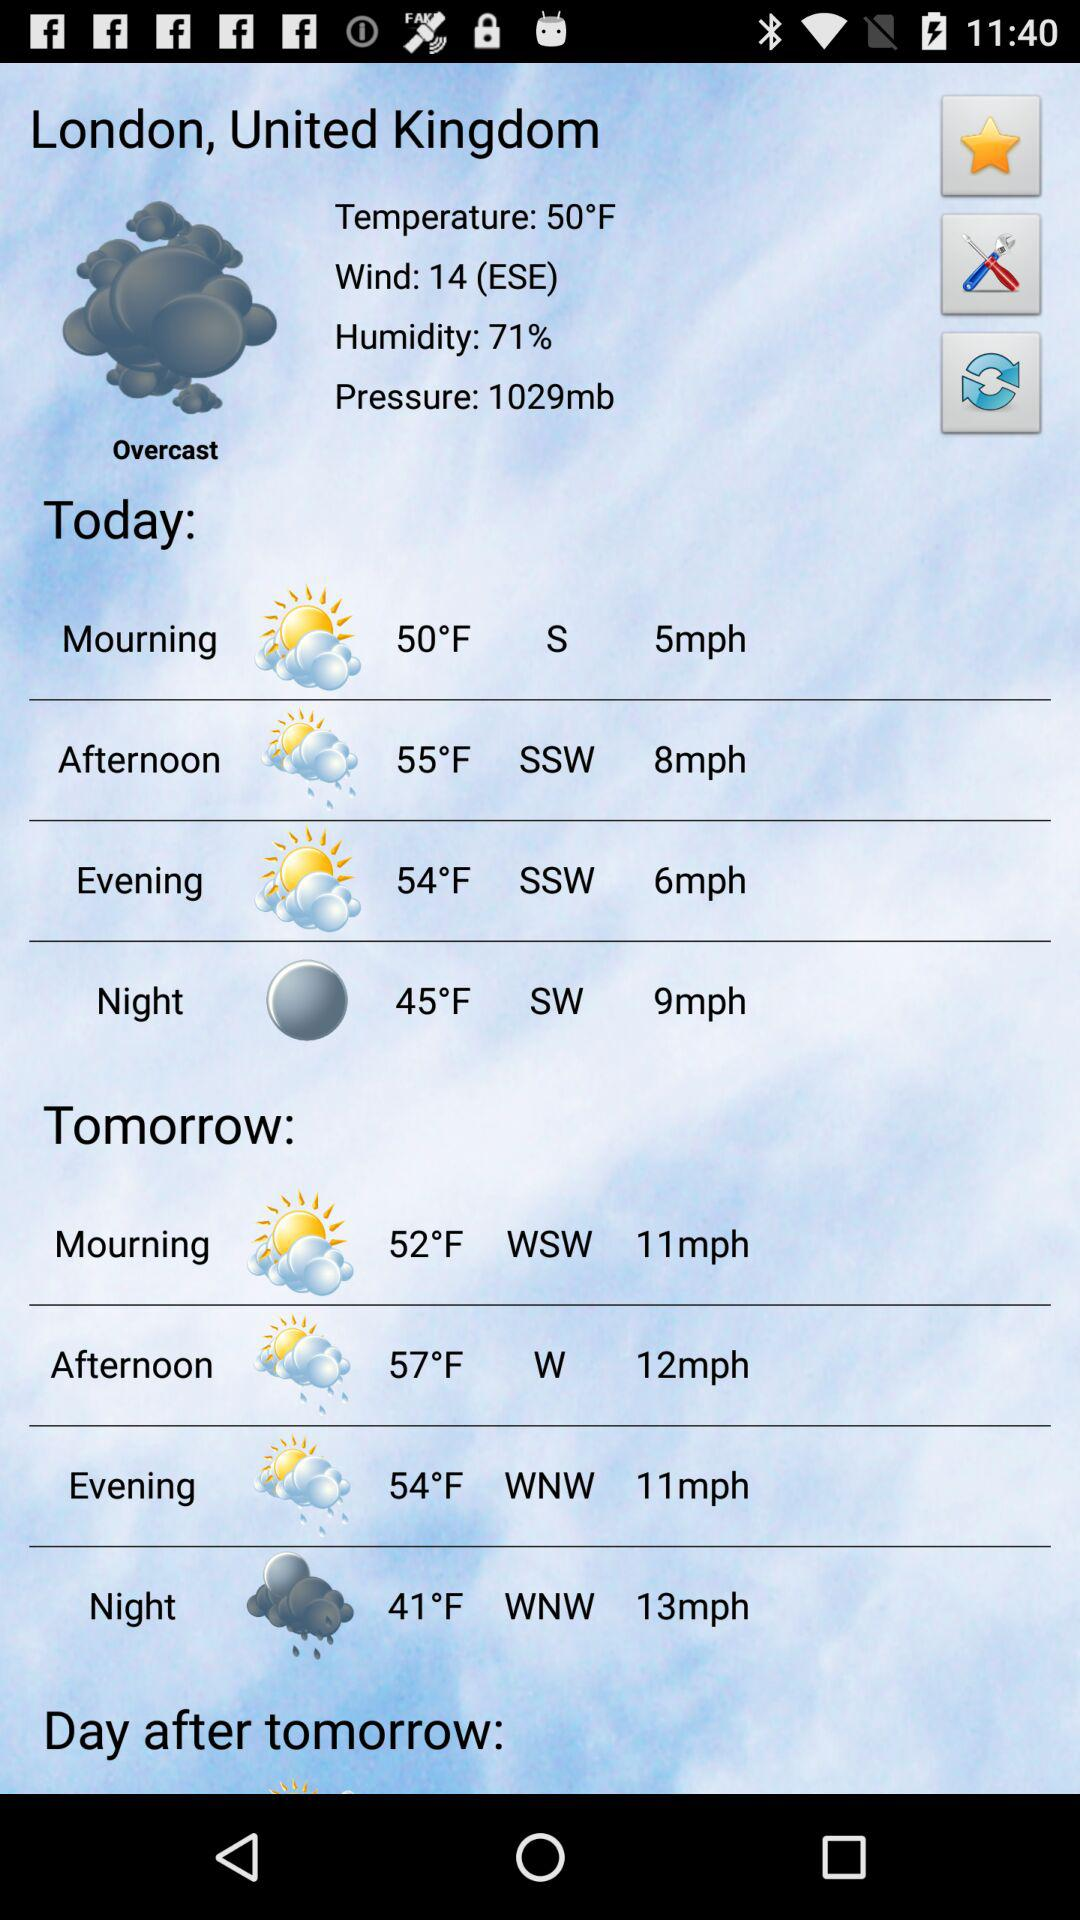What will be the temperature tomorrow morning? The temperature will be 52 degrees Fahrenheit tomorrow morning. 